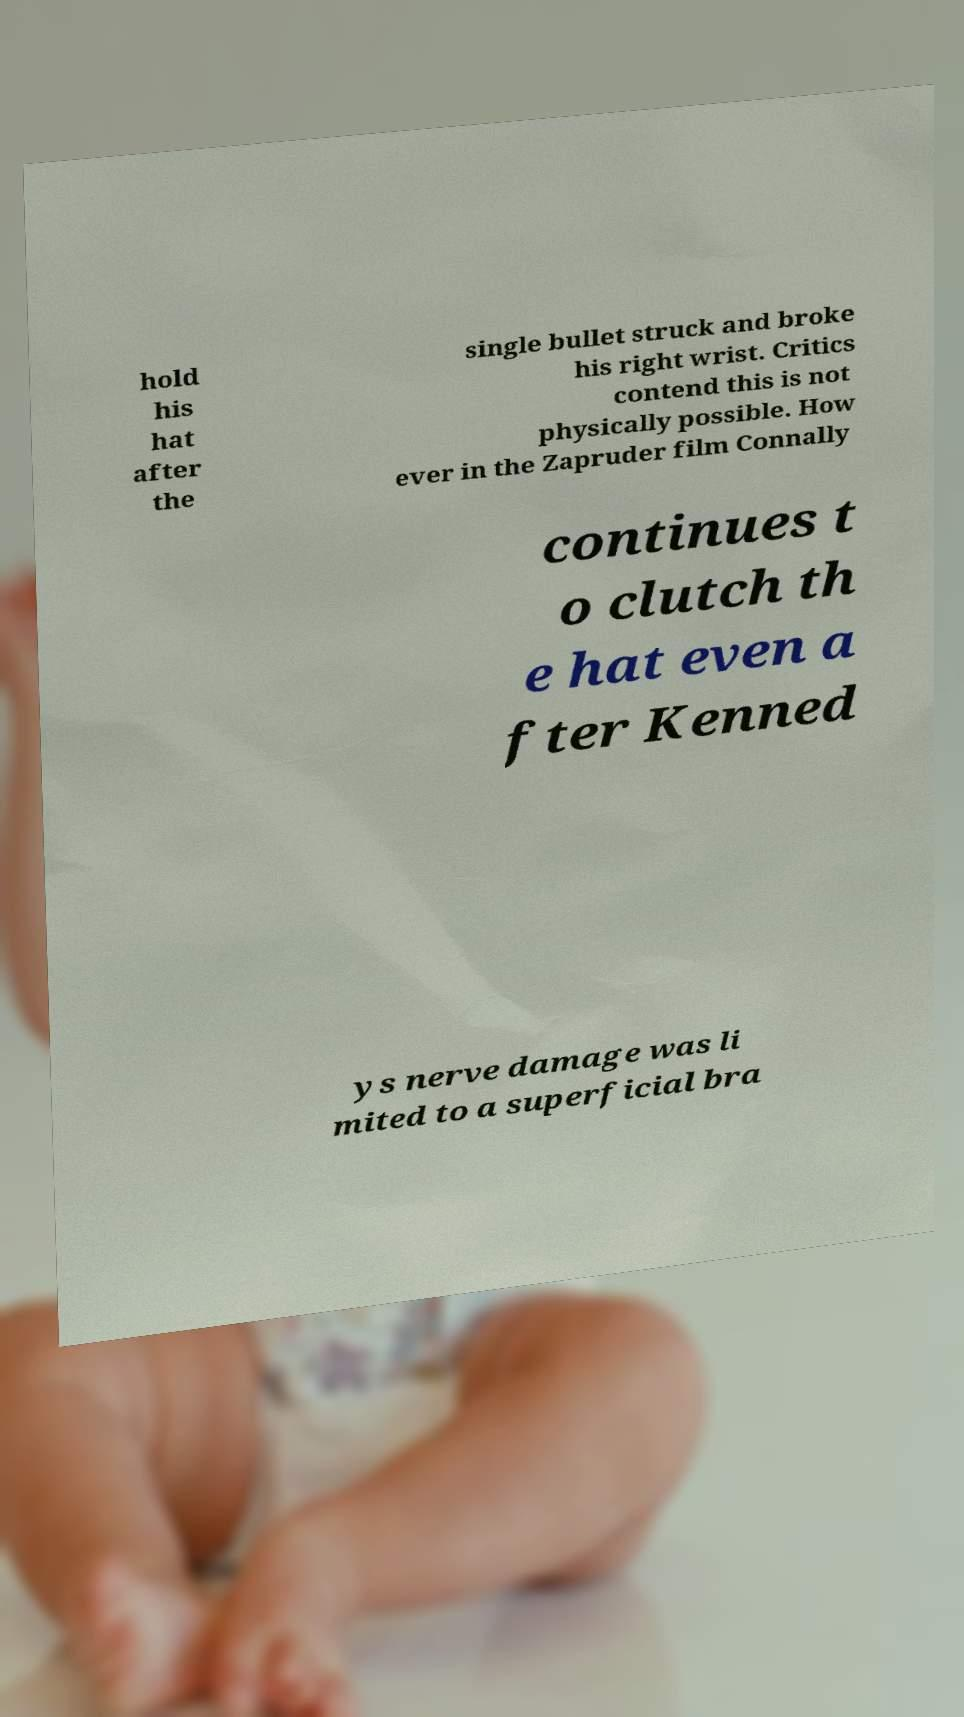What messages or text are displayed in this image? I need them in a readable, typed format. hold his hat after the single bullet struck and broke his right wrist. Critics contend this is not physically possible. How ever in the Zapruder film Connally continues t o clutch th e hat even a fter Kenned ys nerve damage was li mited to a superficial bra 